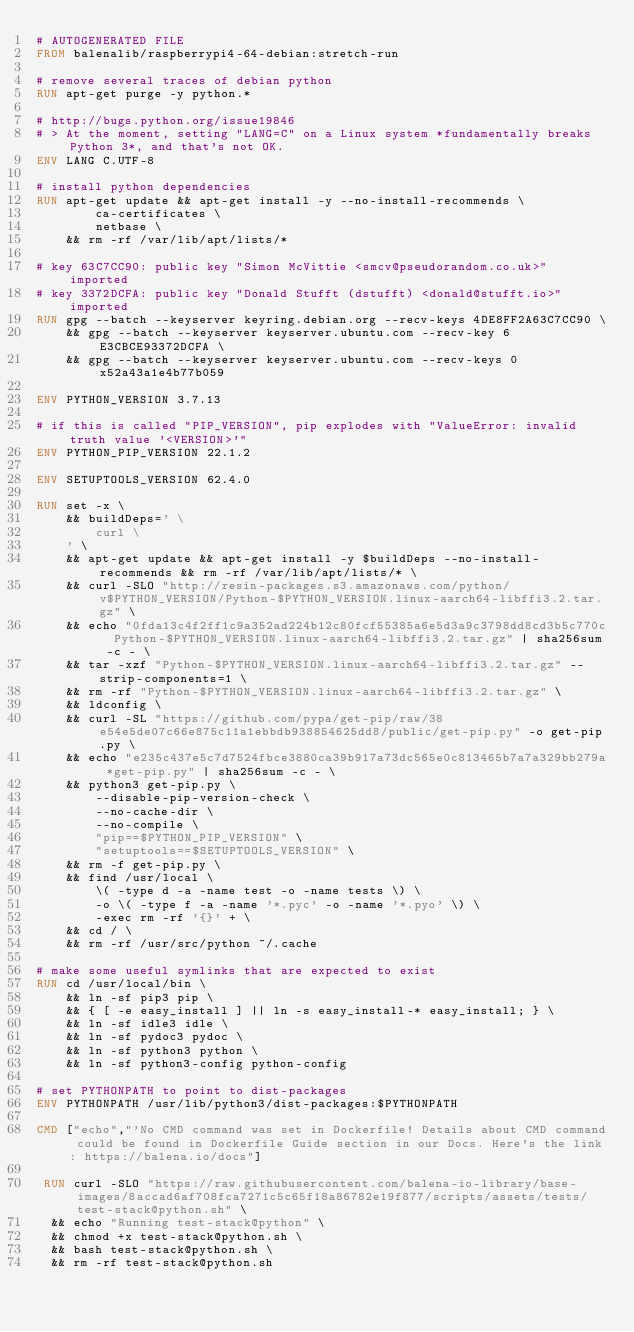<code> <loc_0><loc_0><loc_500><loc_500><_Dockerfile_># AUTOGENERATED FILE
FROM balenalib/raspberrypi4-64-debian:stretch-run

# remove several traces of debian python
RUN apt-get purge -y python.*

# http://bugs.python.org/issue19846
# > At the moment, setting "LANG=C" on a Linux system *fundamentally breaks Python 3*, and that's not OK.
ENV LANG C.UTF-8

# install python dependencies
RUN apt-get update && apt-get install -y --no-install-recommends \
		ca-certificates \
		netbase \
	&& rm -rf /var/lib/apt/lists/*

# key 63C7CC90: public key "Simon McVittie <smcv@pseudorandom.co.uk>" imported
# key 3372DCFA: public key "Donald Stufft (dstufft) <donald@stufft.io>" imported
RUN gpg --batch --keyserver keyring.debian.org --recv-keys 4DE8FF2A63C7CC90 \
	&& gpg --batch --keyserver keyserver.ubuntu.com --recv-key 6E3CBCE93372DCFA \
	&& gpg --batch --keyserver keyserver.ubuntu.com --recv-keys 0x52a43a1e4b77b059

ENV PYTHON_VERSION 3.7.13

# if this is called "PIP_VERSION", pip explodes with "ValueError: invalid truth value '<VERSION>'"
ENV PYTHON_PIP_VERSION 22.1.2

ENV SETUPTOOLS_VERSION 62.4.0

RUN set -x \
	&& buildDeps=' \
		curl \
	' \
	&& apt-get update && apt-get install -y $buildDeps --no-install-recommends && rm -rf /var/lib/apt/lists/* \
	&& curl -SLO "http://resin-packages.s3.amazonaws.com/python/v$PYTHON_VERSION/Python-$PYTHON_VERSION.linux-aarch64-libffi3.2.tar.gz" \
	&& echo "0fda13c4f2ff1c9a352ad224b12c80fcf55385a6e5d3a9c3798dd8cd3b5c770c  Python-$PYTHON_VERSION.linux-aarch64-libffi3.2.tar.gz" | sha256sum -c - \
	&& tar -xzf "Python-$PYTHON_VERSION.linux-aarch64-libffi3.2.tar.gz" --strip-components=1 \
	&& rm -rf "Python-$PYTHON_VERSION.linux-aarch64-libffi3.2.tar.gz" \
	&& ldconfig \
	&& curl -SL "https://github.com/pypa/get-pip/raw/38e54e5de07c66e875c11a1ebbdb938854625dd8/public/get-pip.py" -o get-pip.py \
    && echo "e235c437e5c7d7524fbce3880ca39b917a73dc565e0c813465b7a7a329bb279a *get-pip.py" | sha256sum -c - \
    && python3 get-pip.py \
        --disable-pip-version-check \
        --no-cache-dir \
        --no-compile \
        "pip==$PYTHON_PIP_VERSION" \
        "setuptools==$SETUPTOOLS_VERSION" \
	&& rm -f get-pip.py \
	&& find /usr/local \
		\( -type d -a -name test -o -name tests \) \
		-o \( -type f -a -name '*.pyc' -o -name '*.pyo' \) \
		-exec rm -rf '{}' + \
	&& cd / \
	&& rm -rf /usr/src/python ~/.cache

# make some useful symlinks that are expected to exist
RUN cd /usr/local/bin \
	&& ln -sf pip3 pip \
	&& { [ -e easy_install ] || ln -s easy_install-* easy_install; } \
	&& ln -sf idle3 idle \
	&& ln -sf pydoc3 pydoc \
	&& ln -sf python3 python \
	&& ln -sf python3-config python-config

# set PYTHONPATH to point to dist-packages
ENV PYTHONPATH /usr/lib/python3/dist-packages:$PYTHONPATH

CMD ["echo","'No CMD command was set in Dockerfile! Details about CMD command could be found in Dockerfile Guide section in our Docs. Here's the link: https://balena.io/docs"]

 RUN curl -SLO "https://raw.githubusercontent.com/balena-io-library/base-images/8accad6af708fca7271c5c65f18a86782e19f877/scripts/assets/tests/test-stack@python.sh" \
  && echo "Running test-stack@python" \
  && chmod +x test-stack@python.sh \
  && bash test-stack@python.sh \
  && rm -rf test-stack@python.sh 
</code> 